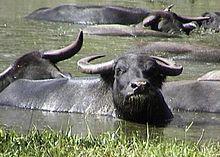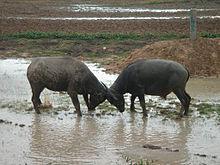The first image is the image on the left, the second image is the image on the right. Assess this claim about the two images: "One image contains exactly two adult oxen.". Correct or not? Answer yes or no. Yes. 